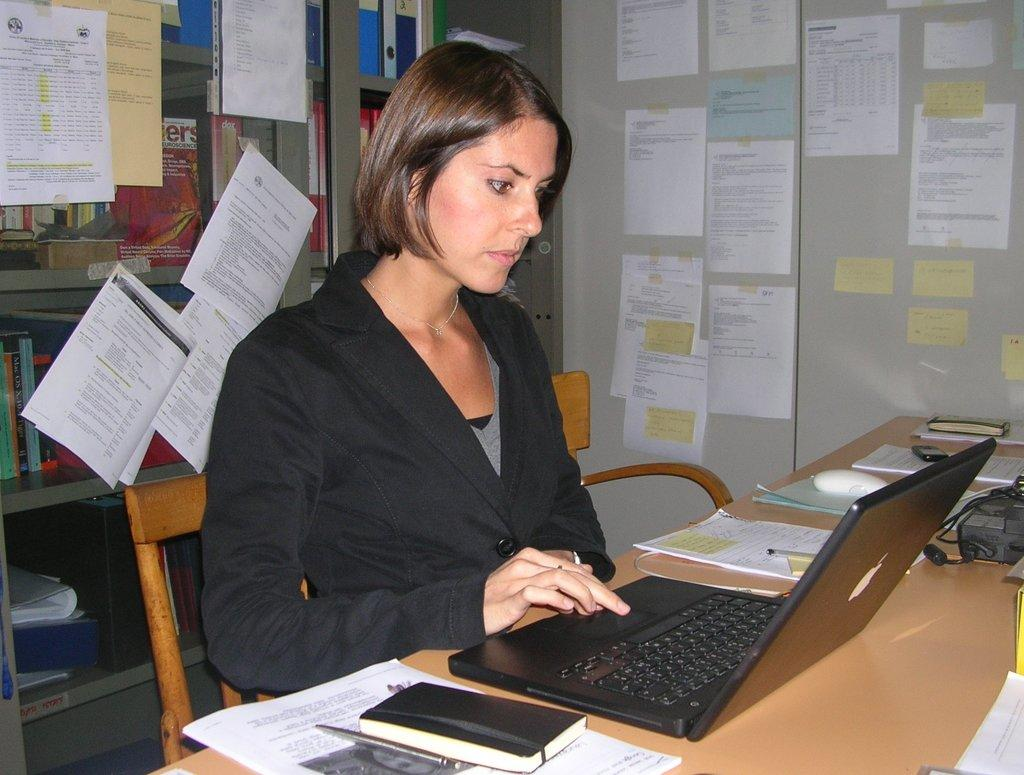Provide a one-sentence caption for the provided image. A pink cover of book is on a shelf behind the woman and shows letters "ers.". 